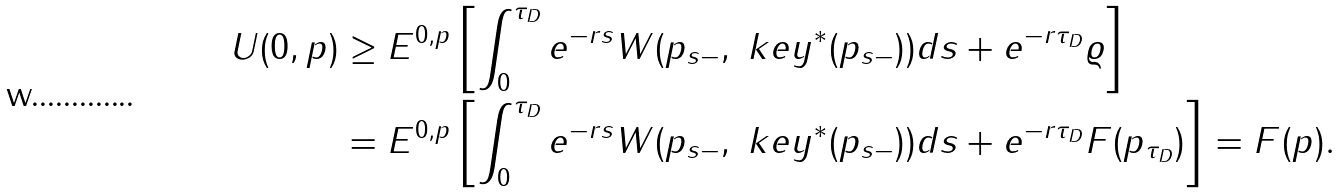Convert formula to latex. <formula><loc_0><loc_0><loc_500><loc_500>U ( 0 , p ) & \geq E ^ { 0 , p } \left [ \int _ { 0 } ^ { \tau _ { D } } { e ^ { - r s } W ( p _ { s - } , \ k e y ^ { * } ( p _ { s - } ) ) d s } + e ^ { - r \tau _ { D } } \varrho \right ] \\ & = E ^ { 0 , p } \left [ \int _ { 0 } ^ { \tau _ { D } } { e ^ { - r s } W ( p _ { s - } , \ k e y ^ { * } ( p _ { s - } ) ) d s } + e ^ { - r \tau _ { D } } F ( p _ { \tau _ { D } } ) \right ] = F ( p ) .</formula> 